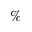Convert formula to latex. <formula><loc_0><loc_0><loc_500><loc_500>\%</formula> 